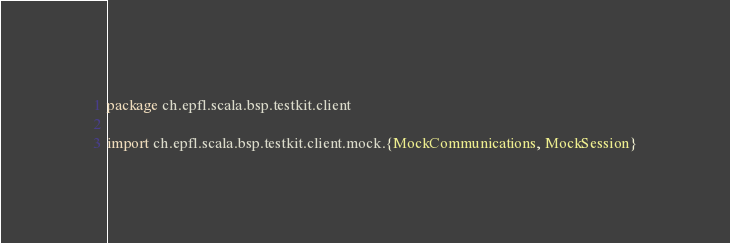<code> <loc_0><loc_0><loc_500><loc_500><_Scala_>package ch.epfl.scala.bsp.testkit.client

import ch.epfl.scala.bsp.testkit.client.mock.{MockCommunications, MockSession}</code> 